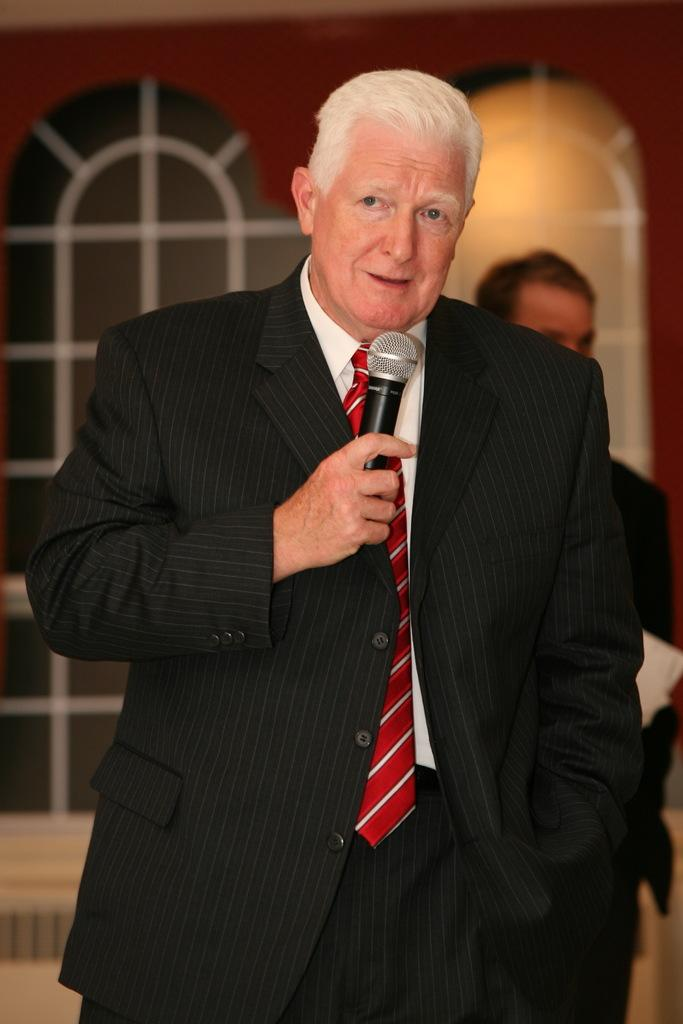Who is the main subject in the image? The main subject in the image is an old man. What is the old man holding in the image? The old man is holding a microphone. What is the old man's facial expression in the image? The old man is smiling in the image. Who is the old man looking at in the image? The old man is looking at someone else in the image. Can you describe the other person in the image? There is another person standing in the background of the image. What type of egg is being used to take notes in the image? There is no egg or note-taking activity present in the image. What effect does the old man's smile have on the person he is looking at in the image? The provided facts do not mention any effect the old man's smile has on the person he is looking at. 